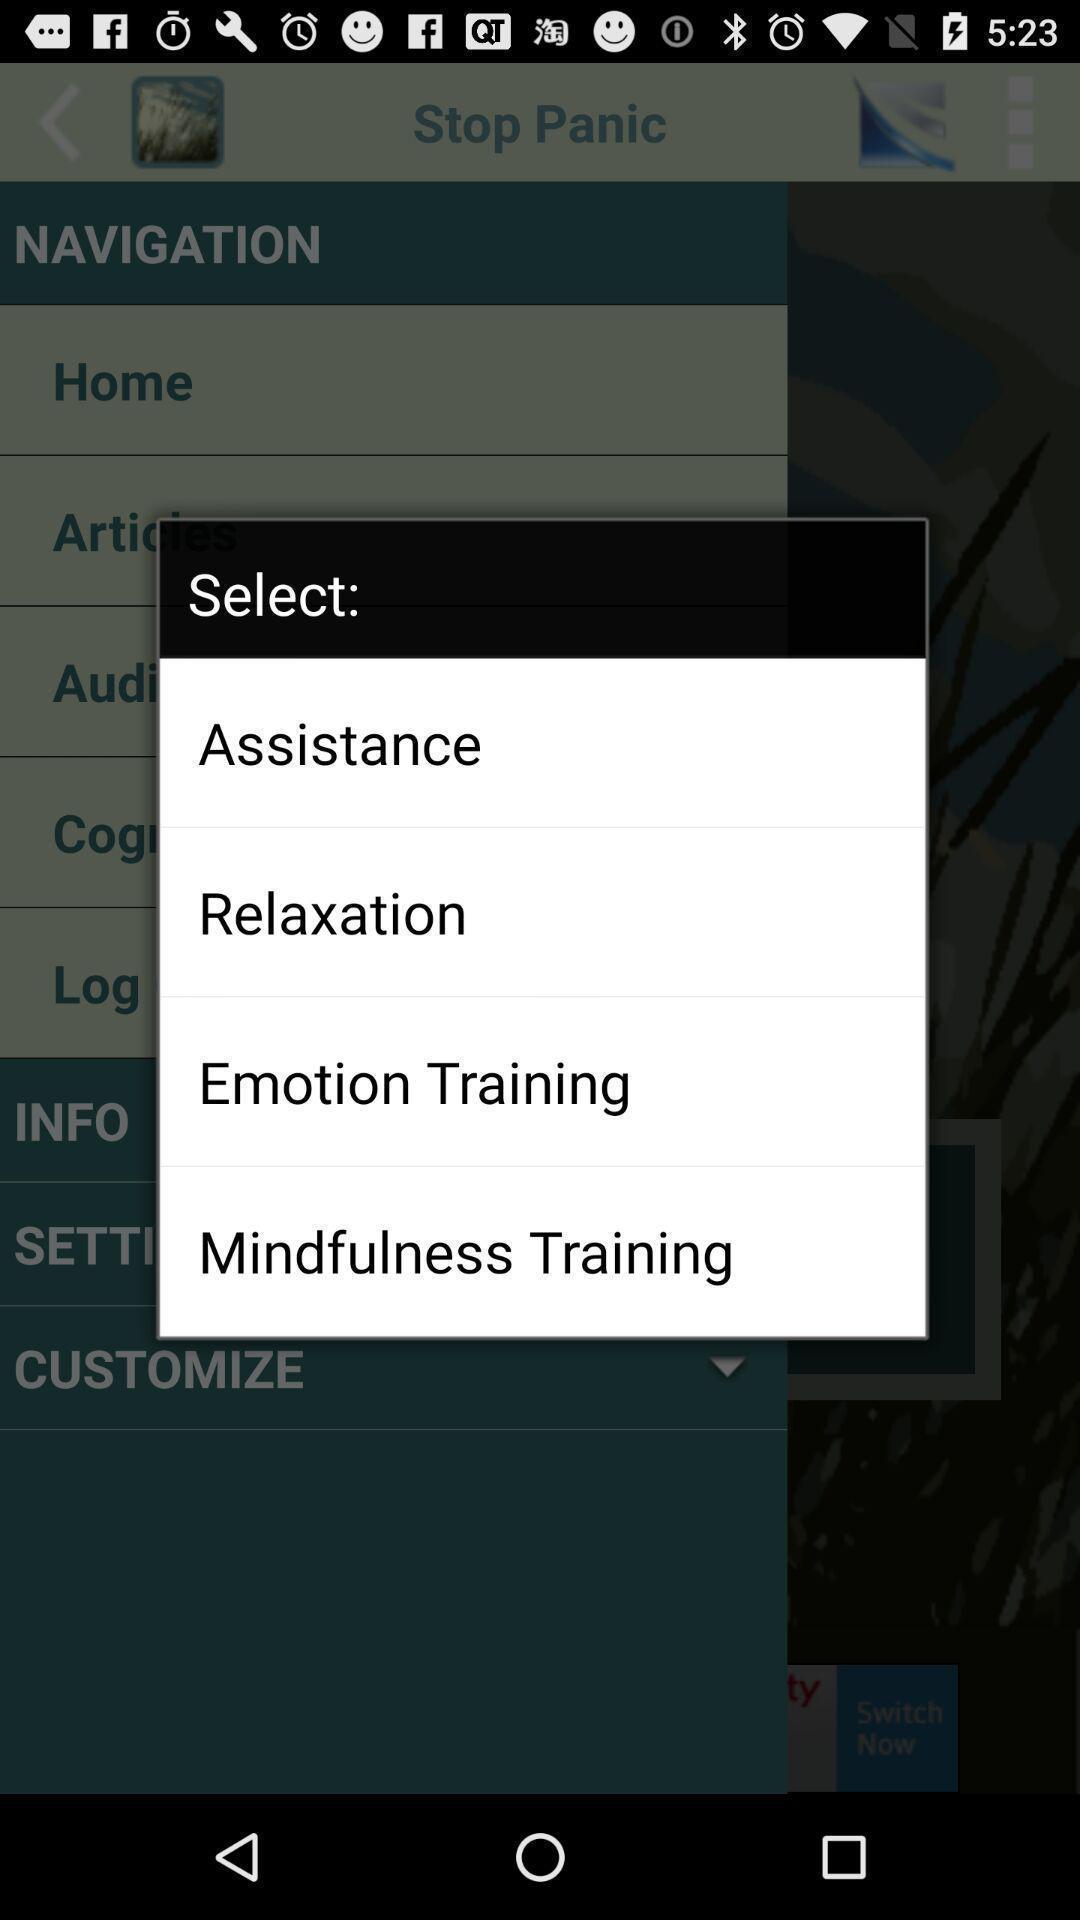Summarize the main components in this picture. Pop-up showing different options to select. 